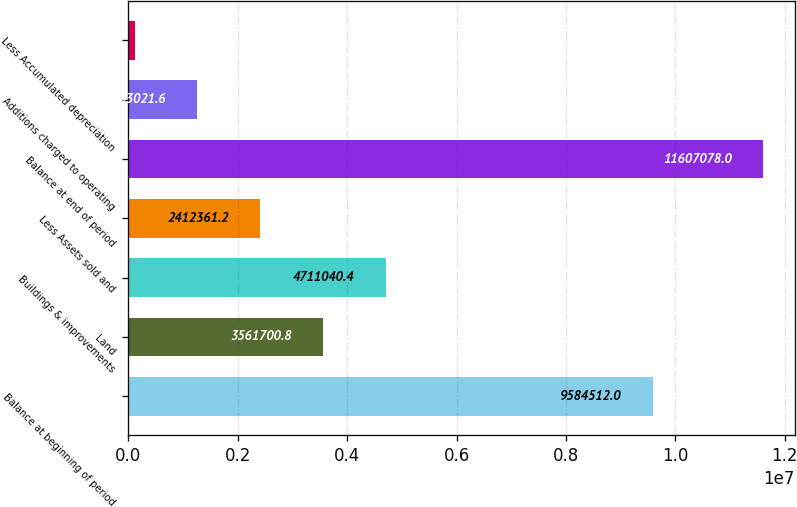<chart> <loc_0><loc_0><loc_500><loc_500><bar_chart><fcel>Balance at beginning of period<fcel>Land<fcel>Buildings & improvements<fcel>Less Assets sold and<fcel>Balance at end of period<fcel>Additions charged to operating<fcel>Less Accumulated depreciation<nl><fcel>9.58451e+06<fcel>3.5617e+06<fcel>4.71104e+06<fcel>2.41236e+06<fcel>1.16071e+07<fcel>1.26302e+06<fcel>113682<nl></chart> 